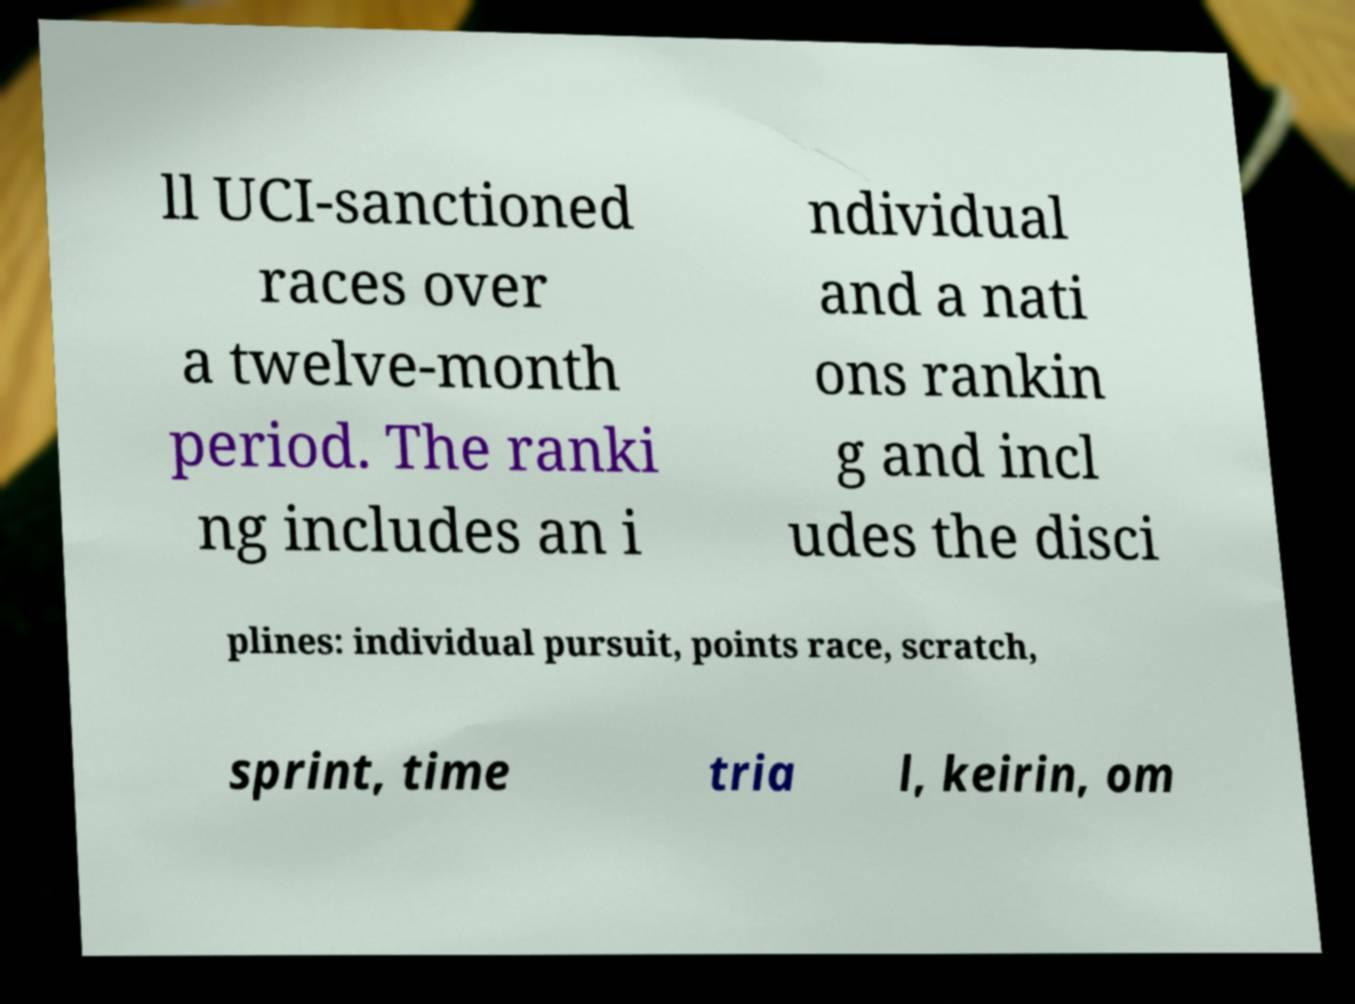I need the written content from this picture converted into text. Can you do that? ll UCI-sanctioned races over a twelve-month period. The ranki ng includes an i ndividual and a nati ons rankin g and incl udes the disci plines: individual pursuit, points race, scratch, sprint, time tria l, keirin, om 